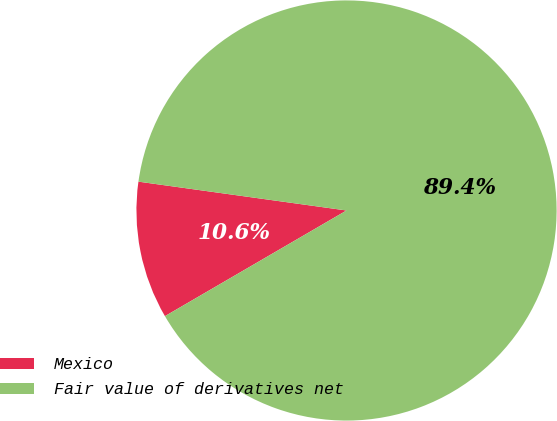<chart> <loc_0><loc_0><loc_500><loc_500><pie_chart><fcel>Mexico<fcel>Fair value of derivatives net<nl><fcel>10.58%<fcel>89.42%<nl></chart> 